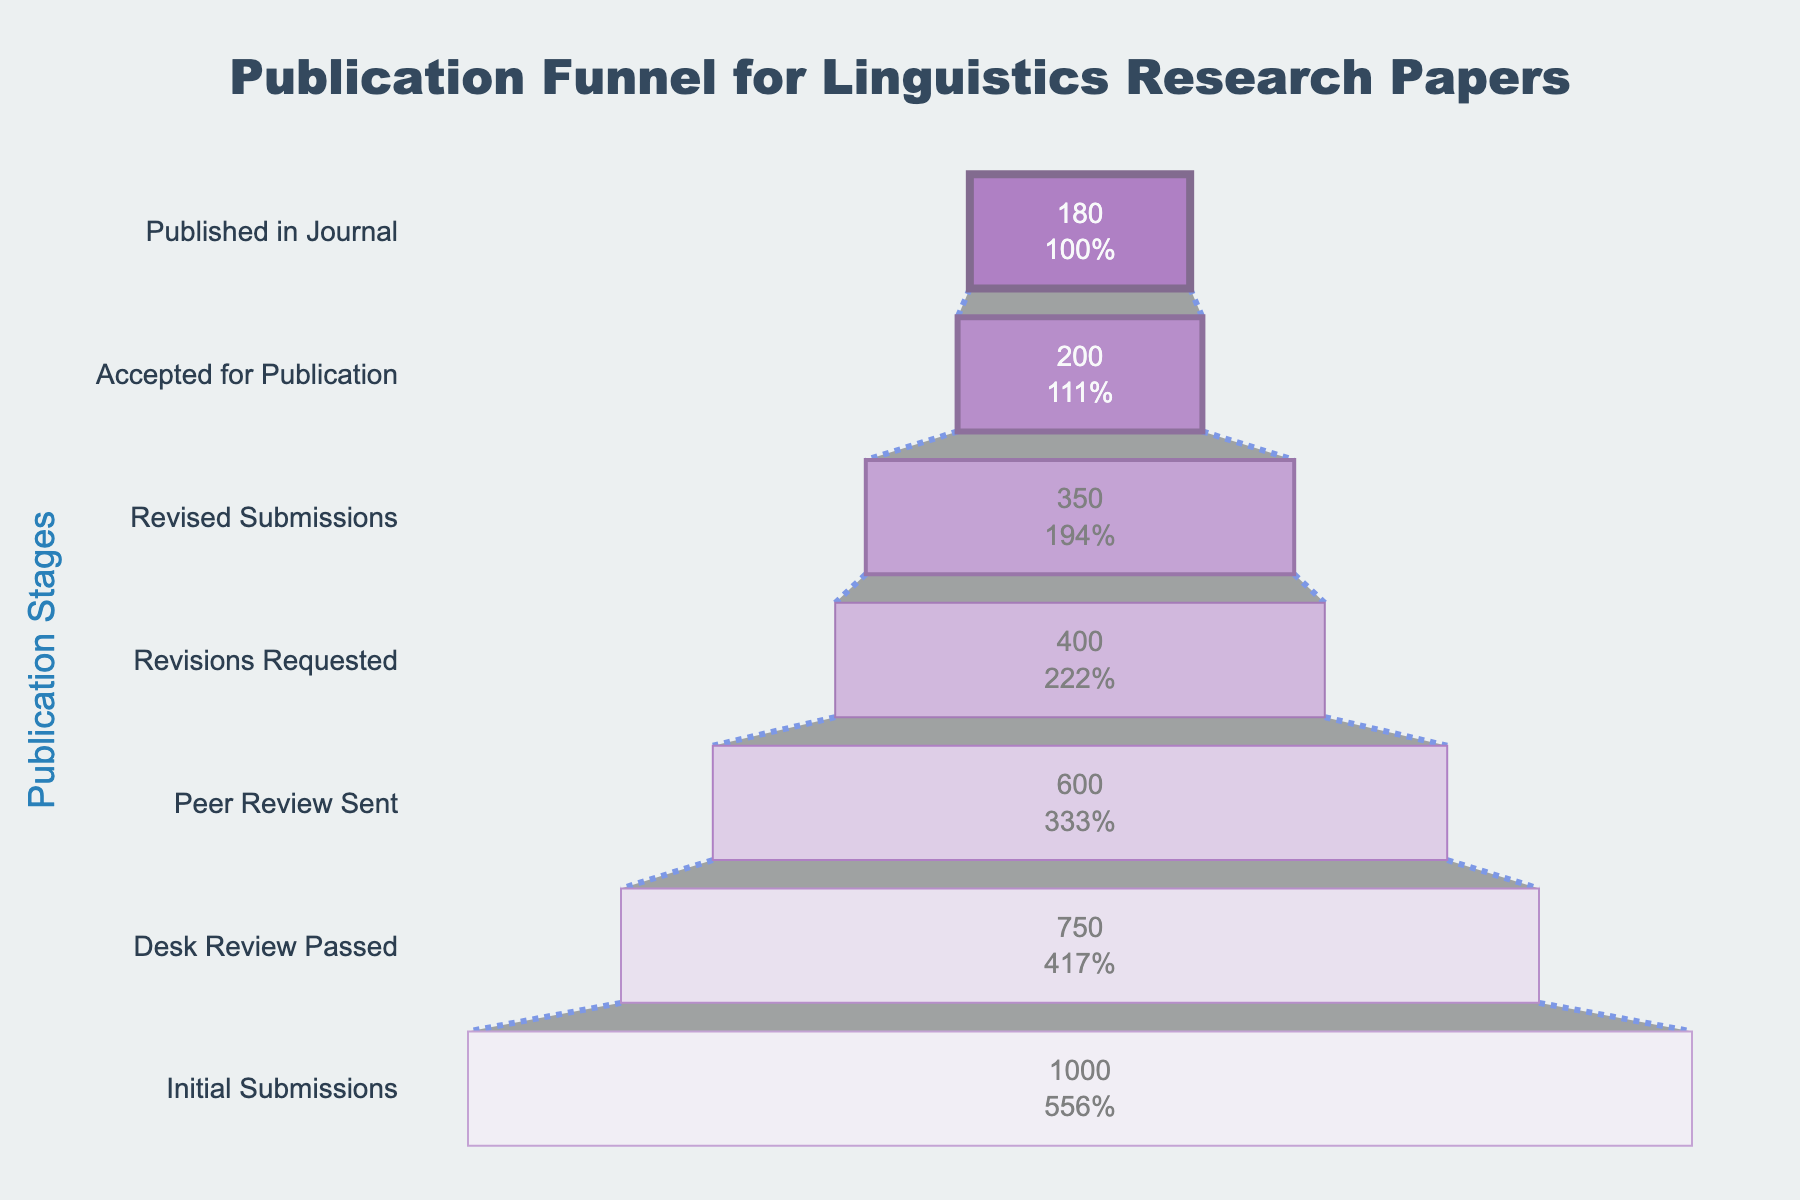What's the title of the funnel chart? The title is mentioned at the top of the figure. It is usually the largest and most prominent text.
Answer: Publication Funnel for Linguistics Research Papers How many papers pass the desk review? The number of papers passing the desk review can be found at the "Desk Review Passed" stage in the figure.
Answer: 750 What percentage of initial submissions made it through to the peer review stage? To find this percentage, divide the number of papers sent for peer review by the initial submissions, and then multiply by 100. (600 / 1000) * 100
Answer: 60% How many papers are published in the journal? The number can be found at the last ("Published in Journal") stage in the funnel chart.
Answer: 180 What stage has the highest drop-off in the number of papers? The largest difference between consecutive stages occurs between the "Peer Review Sent" (600) and "Revisions Requested" (400) stages.
Answer: Peer Review Sent to Revisions Requested How many total papers were accepted for publication but not published in the journal? Subtract the number of published papers from the number of papers accepted for publication. 200 - 180
Answer: 20 Compare the number of papers that had revisions requested versus the number that passed the desk review. Which is higher and by how much? Compare the numbers at the "Revisions Requested" and "Desk Review Passed" stages. 750 (Desk Review Passed) - 400 (Revisions Requested)
Answer: Desk Review Passed by 350 What is the acceptance rate of revised submissions? Divide the number of papers accepted for publication by the number of revised submissions and multiply by 100. (200 / 350) * 100
Answer: 57.14% What is the proportion of initial submissions that reached the final published stage? Divide the number of published papers by the number of initial submissions, then multiply by 100. (180 / 1000) * 100
Answer: 18% How many papers passed the desk review but were not sent for peer review? Subtract the number sent for peer review from the number that passed the desk review. 750 - 600
Answer: 150 